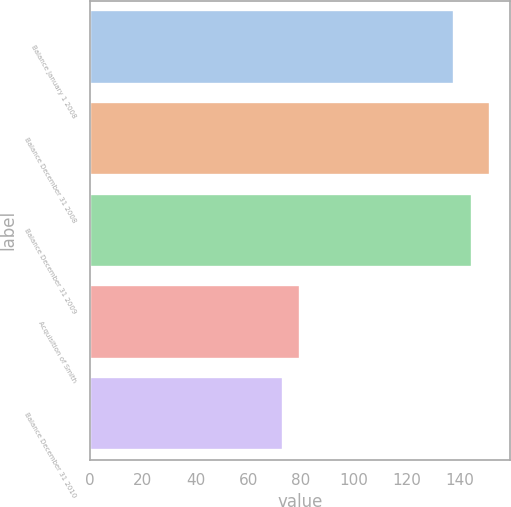Convert chart to OTSL. <chart><loc_0><loc_0><loc_500><loc_500><bar_chart><fcel>Balance January 1 2008<fcel>Balance December 31 2008<fcel>Balance December 31 2009<fcel>Acquisition of Smith<fcel>Balance December 31 2010<nl><fcel>138<fcel>151.4<fcel>144.7<fcel>79.7<fcel>73<nl></chart> 